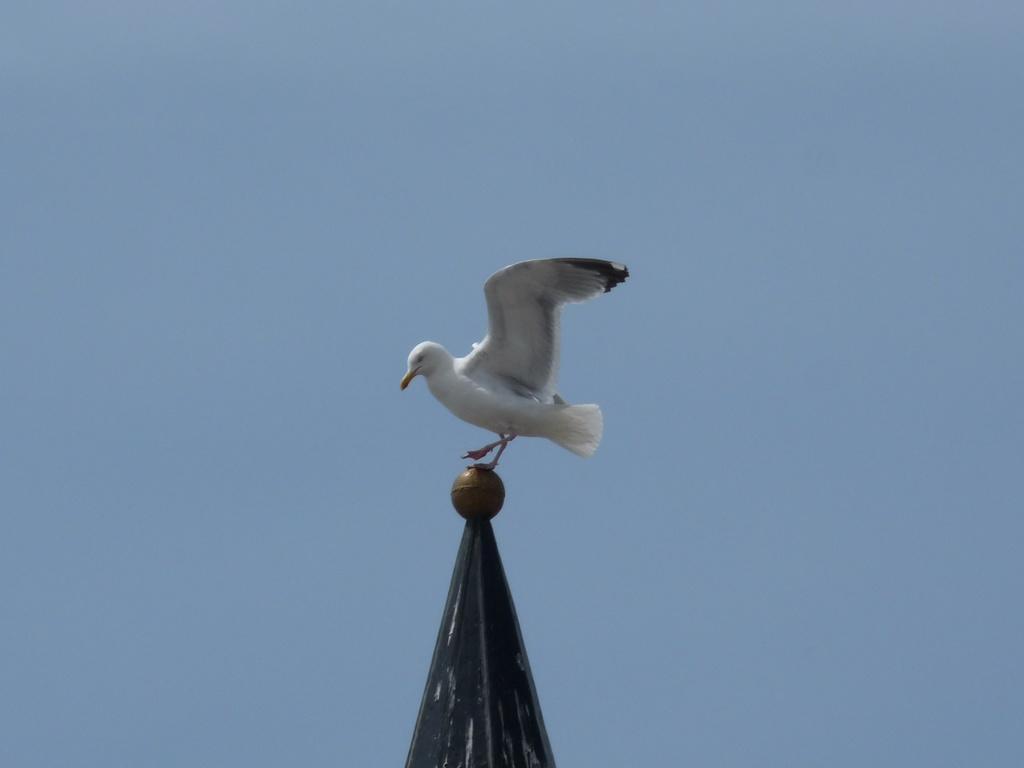Please provide a concise description of this image. In the center of the image we can see one pole. On the pole we can see one round object and one bird, which is in white and black color. In the background we can see the sky. 